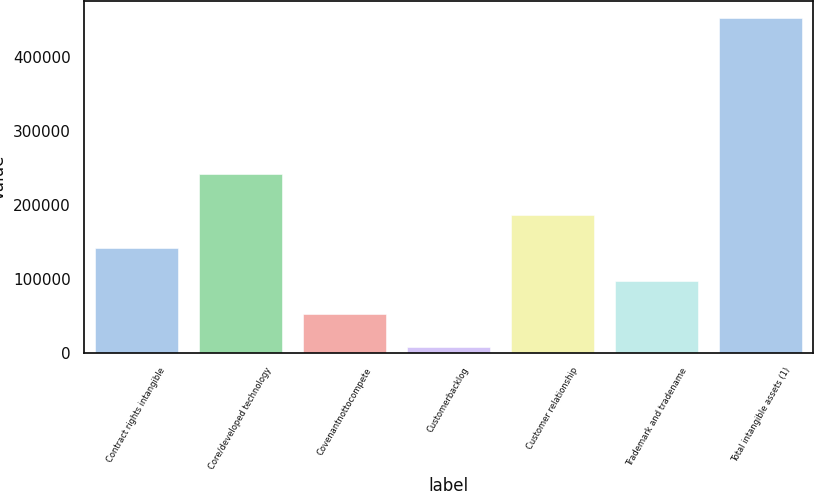Convert chart to OTSL. <chart><loc_0><loc_0><loc_500><loc_500><bar_chart><fcel>Contract rights intangible<fcel>Core/developed technology<fcel>Covenantnottocompete<fcel>Customerbacklog<fcel>Customer relationship<fcel>Trademark and tradename<fcel>Total intangible assets (1)<nl><fcel>141556<fcel>241457<fcel>52698.8<fcel>8270<fcel>185985<fcel>97127.6<fcel>452558<nl></chart> 